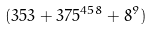<formula> <loc_0><loc_0><loc_500><loc_500>( 3 5 3 + 3 7 5 ^ { 4 5 8 } + 8 ^ { 9 } )</formula> 